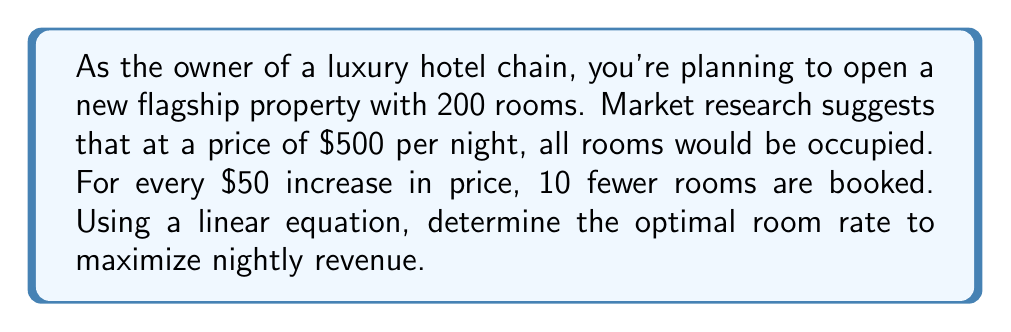Solve this math problem. Let's approach this step-by-step:

1) First, let's define our variables:
   $x$ = number of $50 increments above $500
   $p$ = price per room
   $r$ = number of rooms booked
   $R$ = total revenue

2) We can express price as a function of $x$:
   $p = 500 + 50x$

3) We can express rooms booked as a function of $x$:
   $r = 200 - 10x$

4) Revenue is price times rooms booked:
   $R = p \cdot r = (500 + 50x)(200 - 10x)$

5) Expand this equation:
   $R = 100000 + 5000x - 5000x - 500x^2 = 100000 - 500x^2$

6) To find the maximum revenue, we need to find the vertex of this parabola. The x-coordinate of the vertex occurs at $x = -b/(2a)$ where $a$ and $b$ are the coefficients of the quadratic equation in standard form $(ax^2 + bx + c)$.

7) In this case, $a = -500$ and $b = 0$, so:
   $x = -0 / (2(-500)) = 0$

8) This means the optimal price is when $x = 0$, or in other words, when the price is $500 per night.

9) To calculate the maximum revenue:
   $R = 100000 - 500(0)^2 = 100000$

Therefore, the maximum nightly revenue is $100,000, achieved at a price of $500 per night with all 200 rooms booked.
Answer: $500 per night 